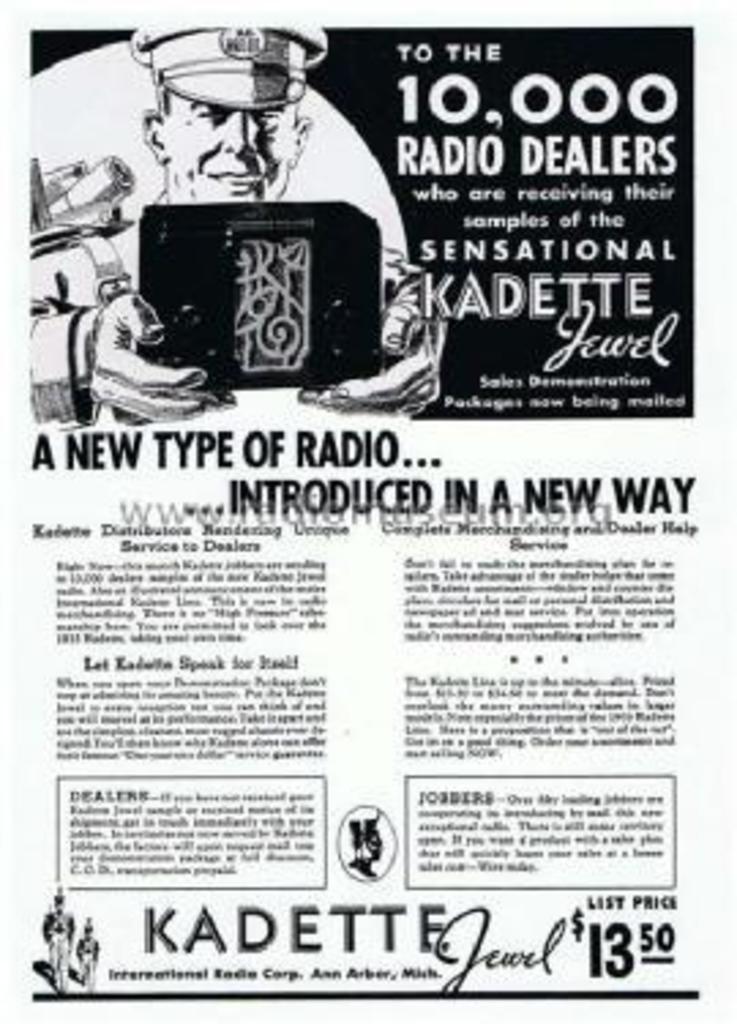What type of radio is introduce?
Give a very brief answer. Kadette jewel. How many radio dealers are there?
Give a very brief answer. 10,000. 